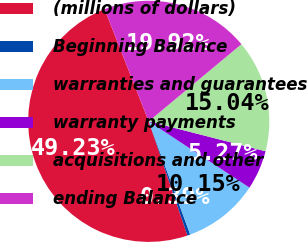<chart> <loc_0><loc_0><loc_500><loc_500><pie_chart><fcel>(millions of dollars)<fcel>Beginning Balance<fcel>warranties and guarantees<fcel>warranty payments<fcel>acquisitions and other<fcel>ending Balance<nl><fcel>49.23%<fcel>0.39%<fcel>10.15%<fcel>5.27%<fcel>15.04%<fcel>19.92%<nl></chart> 